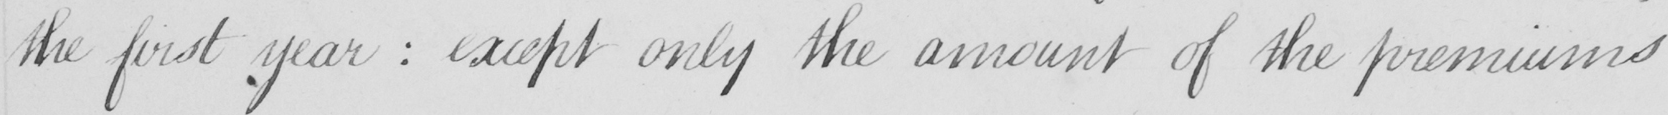Can you tell me what this handwritten text says? the first year  :  except only the amount of the premiums 